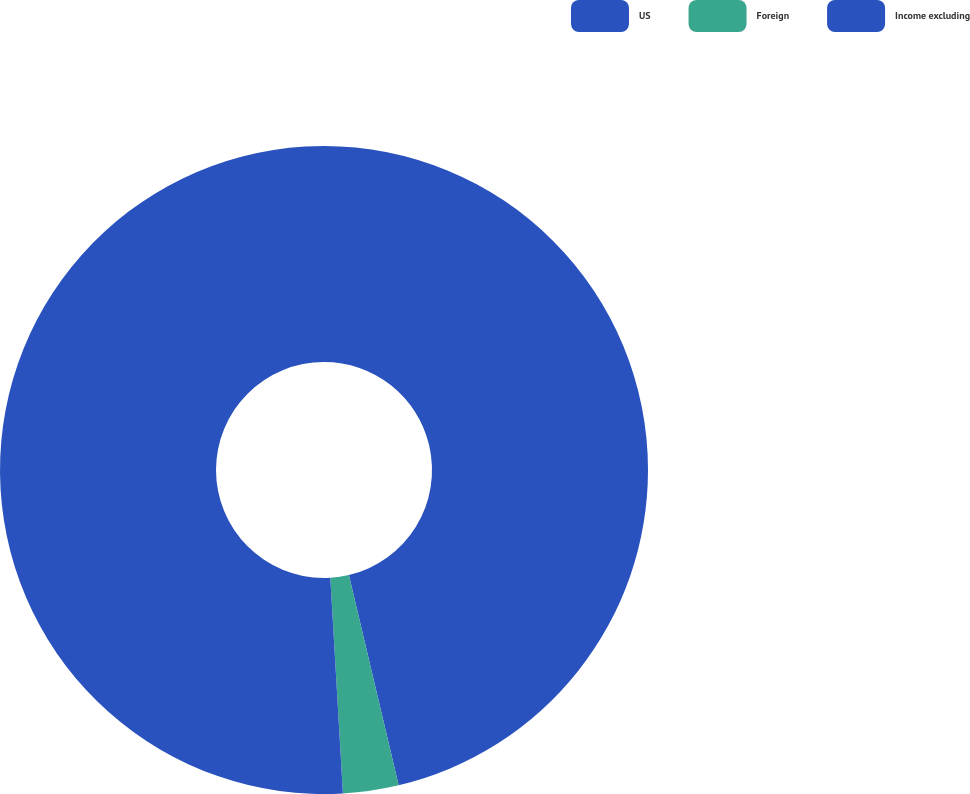Convert chart to OTSL. <chart><loc_0><loc_0><loc_500><loc_500><pie_chart><fcel>US<fcel>Foreign<fcel>Income excluding<nl><fcel>46.3%<fcel>2.77%<fcel>50.93%<nl></chart> 